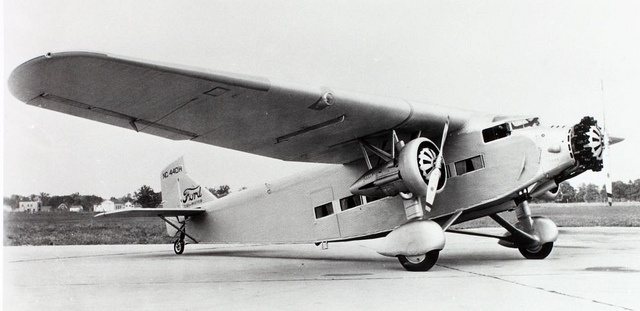Describe the objects in this image and their specific colors. I can see a airplane in white, gray, lightgray, darkgray, and black tones in this image. 